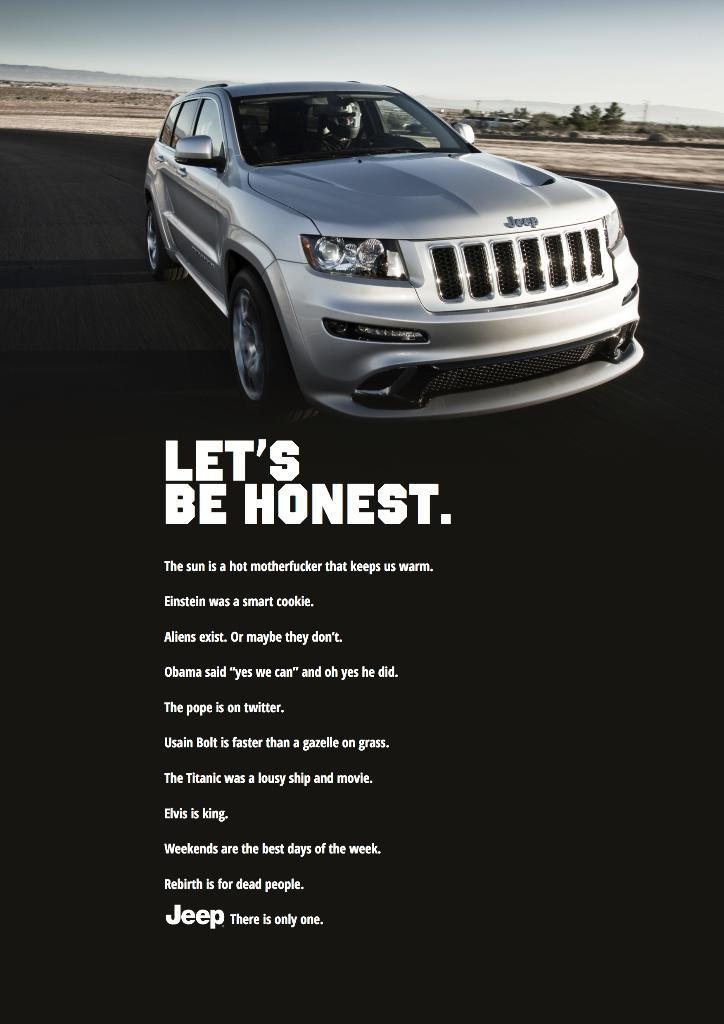What is the main subject of the picture? The main subject of the picture is a car. Are there any words or phrases associated with the car in the image? Yes, there are quotations below the car. Can you tell if the image has been altered in any way? Yes, the image has been edited. of the car is a different color than the rest of the car, indicating that the image has been edited. What type of breakfast is being offered in the image? There is no breakfast present in the image; it features a car with quotations below it. How many stitches are visible on the car in the image? There are no stitches visible on the car in the image; it appears to be a photograph rather than a fabric or textile. 